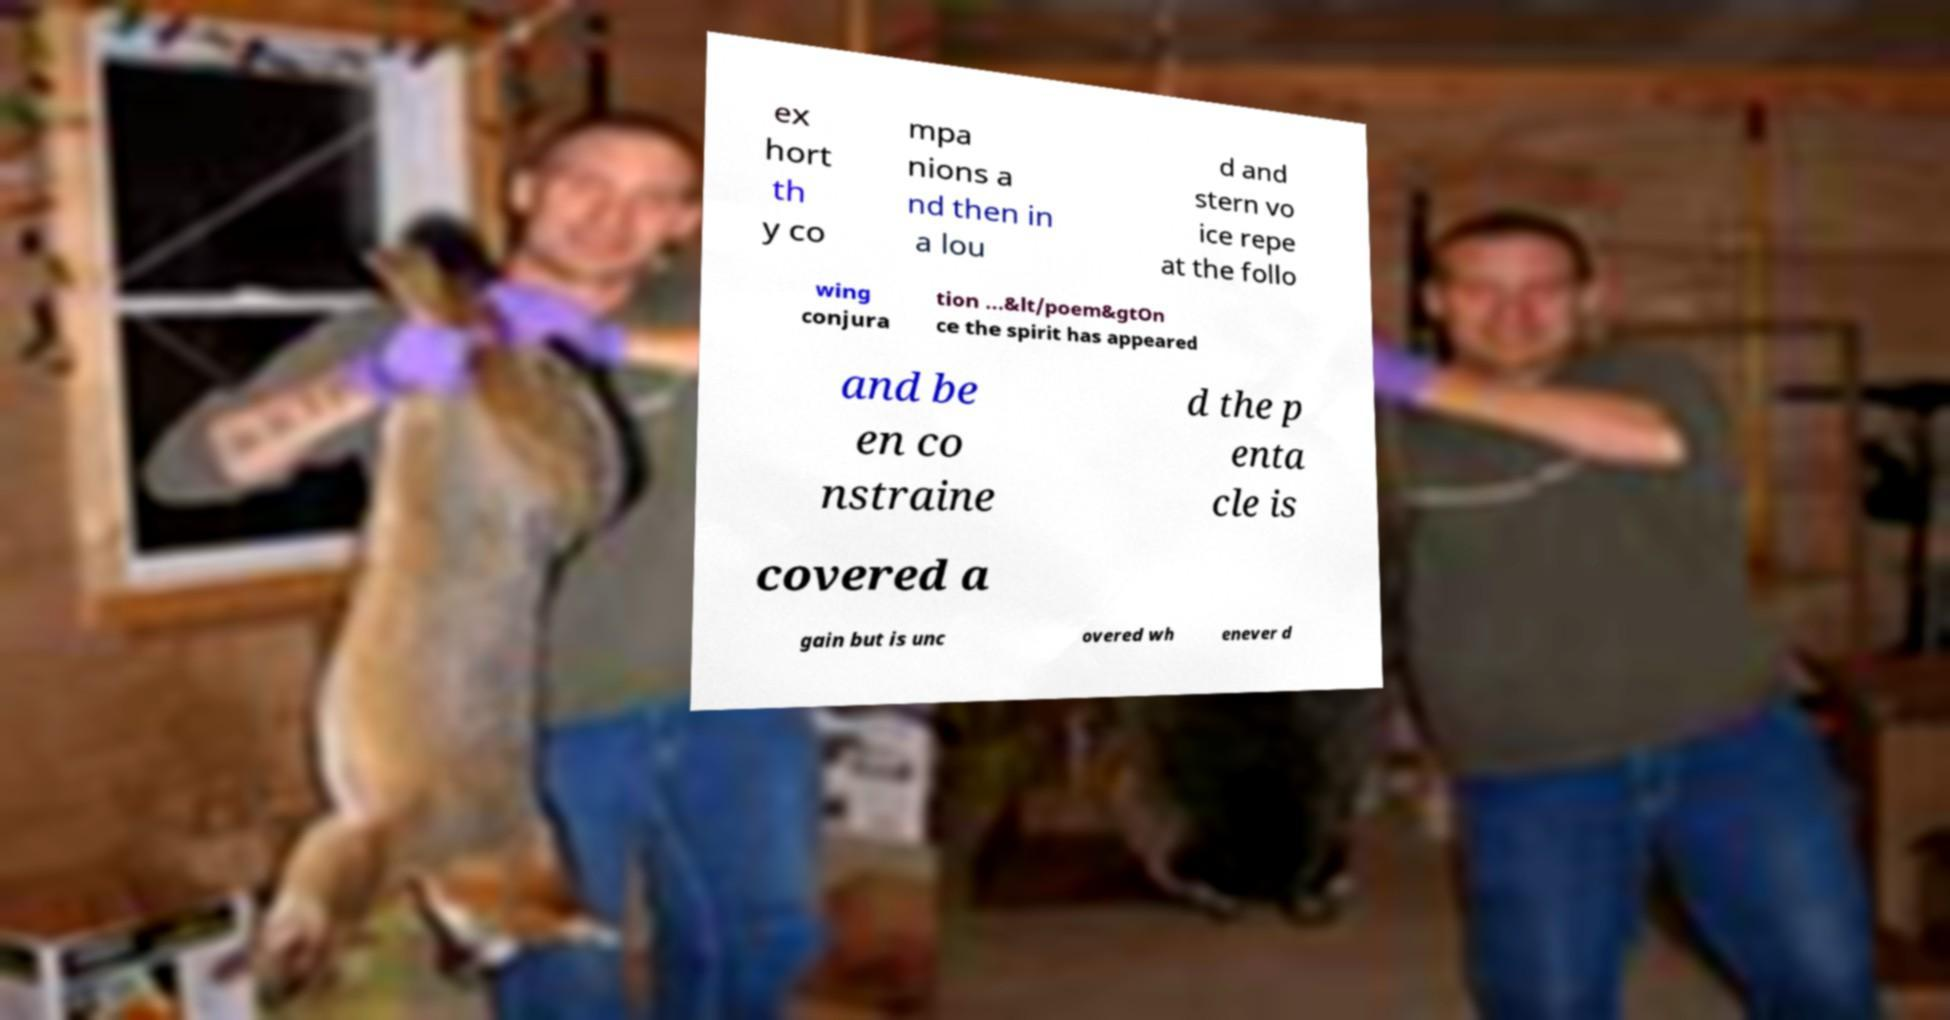For documentation purposes, I need the text within this image transcribed. Could you provide that? ex hort th y co mpa nions a nd then in a lou d and stern vo ice repe at the follo wing conjura tion ...&lt/poem&gtOn ce the spirit has appeared and be en co nstraine d the p enta cle is covered a gain but is unc overed wh enever d 